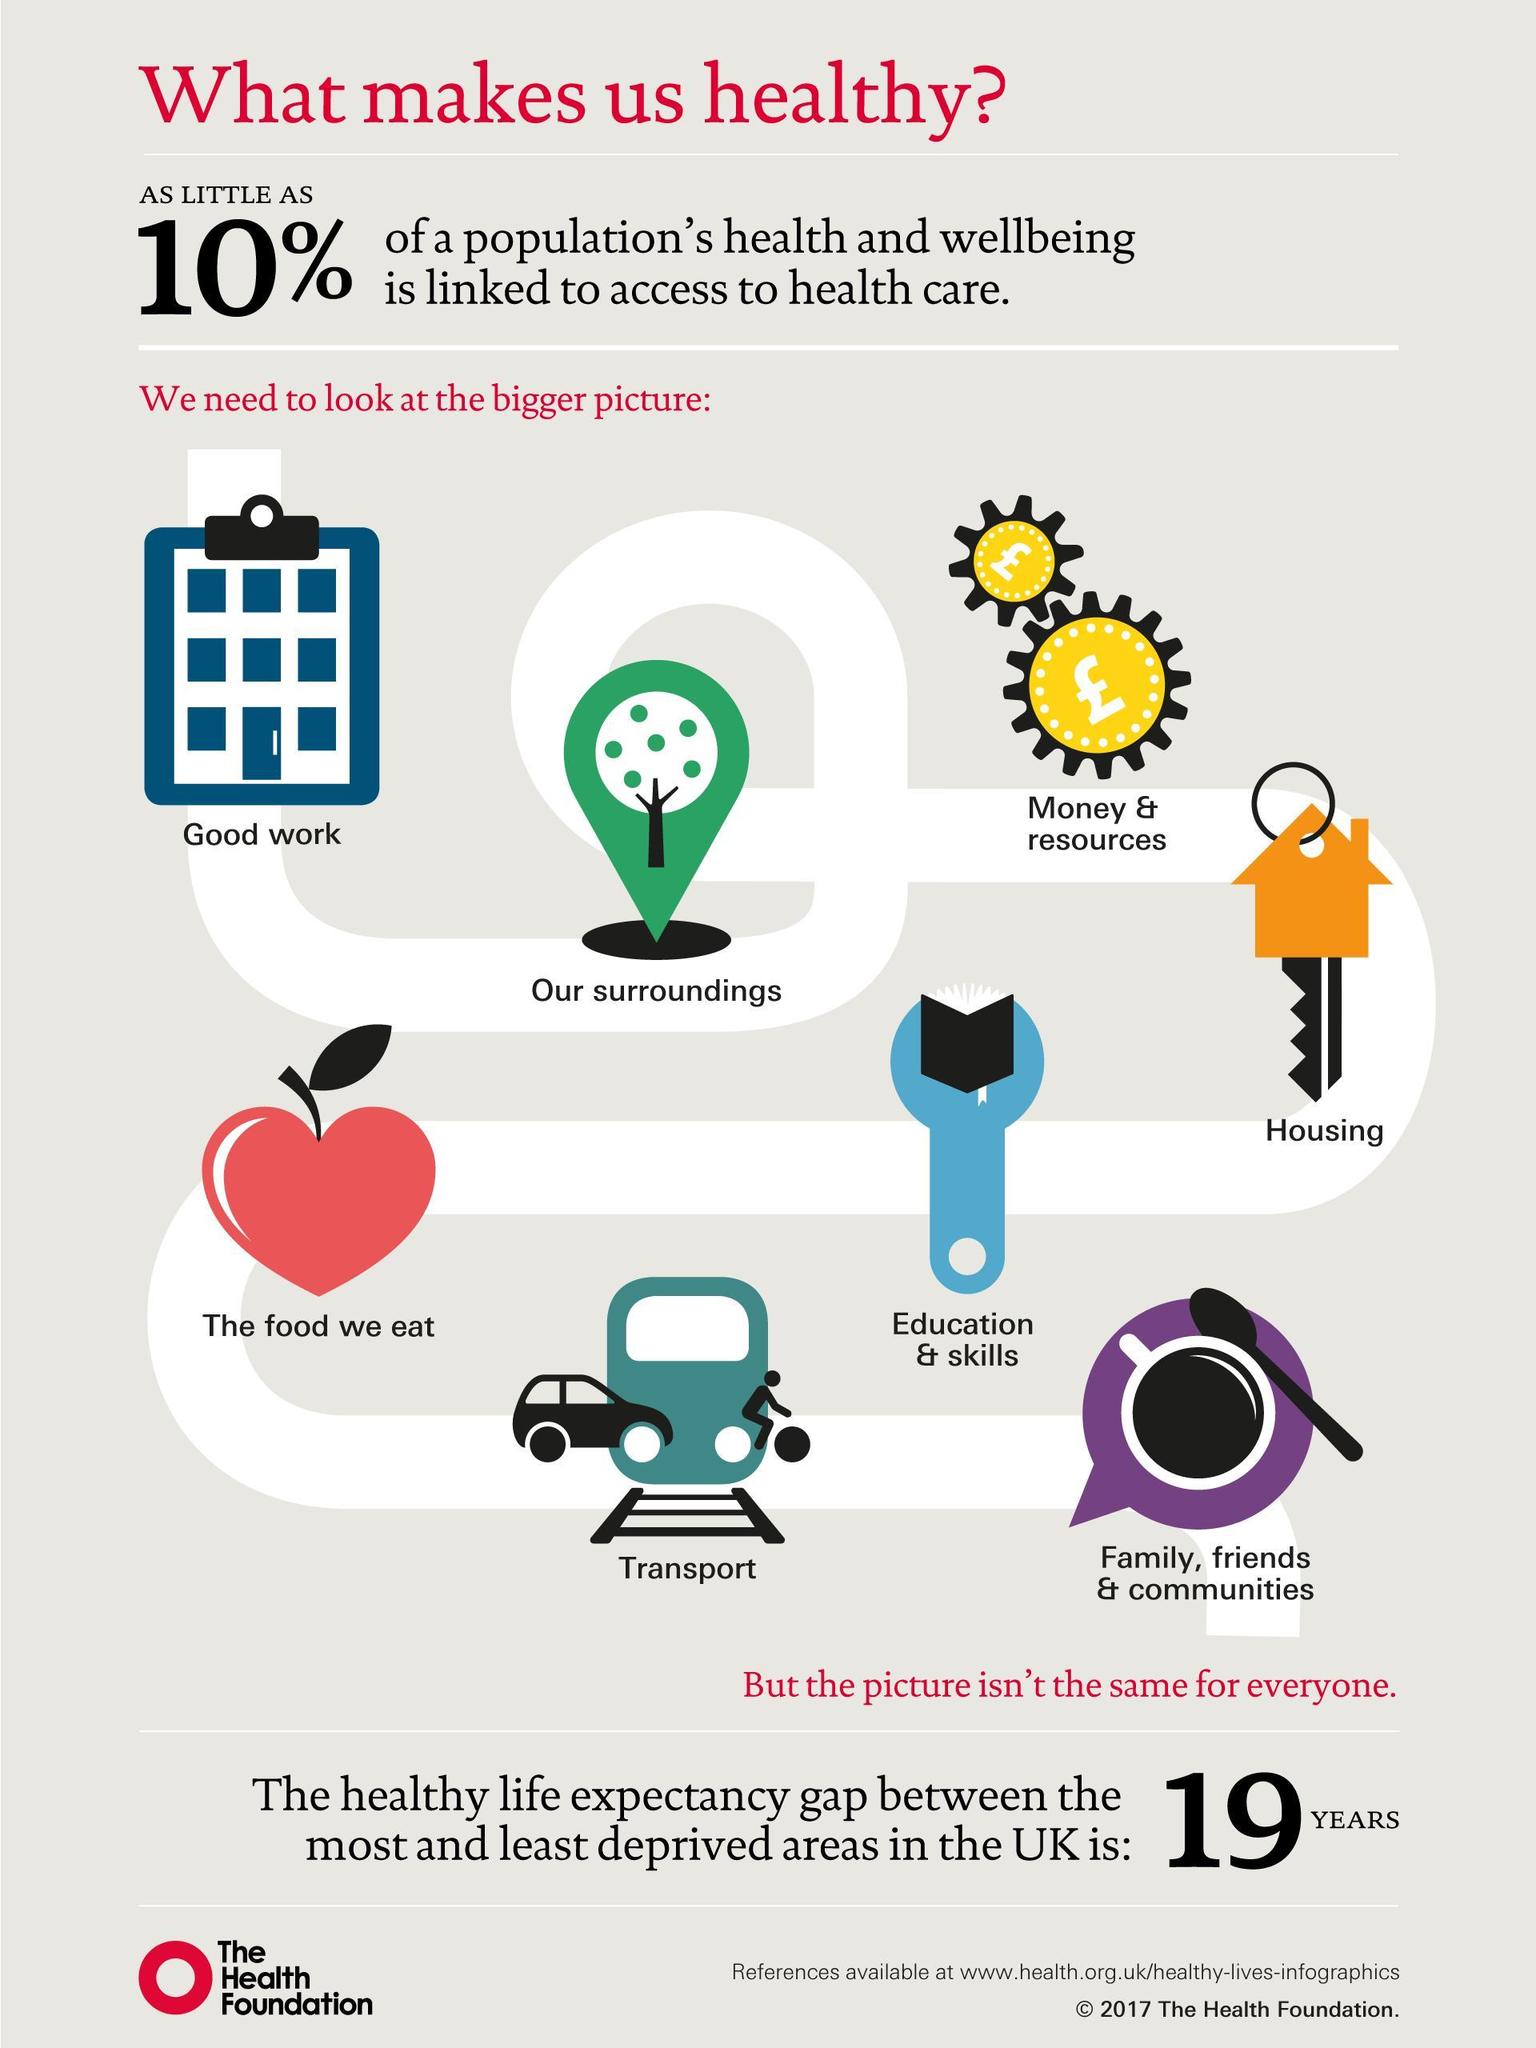What percentage of the population's health and wellbeing is not linked to access to health care?
Answer the question with a short phrase. 90% How many factors affect the population's health? 8 